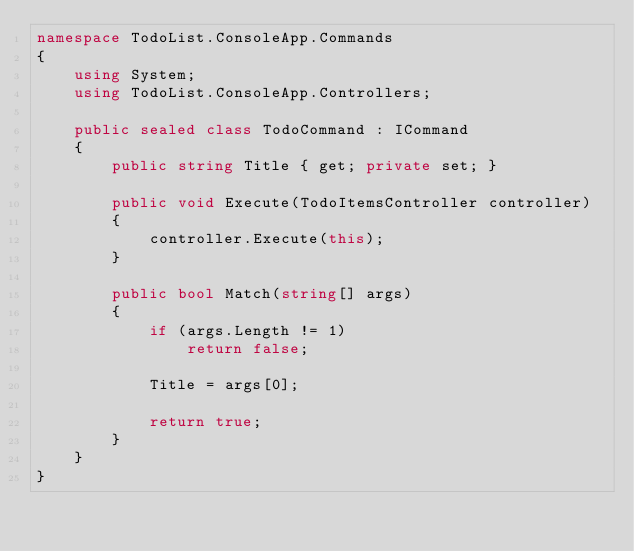Convert code to text. <code><loc_0><loc_0><loc_500><loc_500><_C#_>namespace TodoList.ConsoleApp.Commands
{
    using System;
    using TodoList.ConsoleApp.Controllers;

    public sealed class TodoCommand : ICommand
    {
        public string Title { get; private set; }

        public void Execute(TodoItemsController controller)
        {
            controller.Execute(this);
        }

        public bool Match(string[] args)
        {
            if (args.Length != 1)
                return false;

            Title = args[0];

            return true;
        }
    }
}</code> 